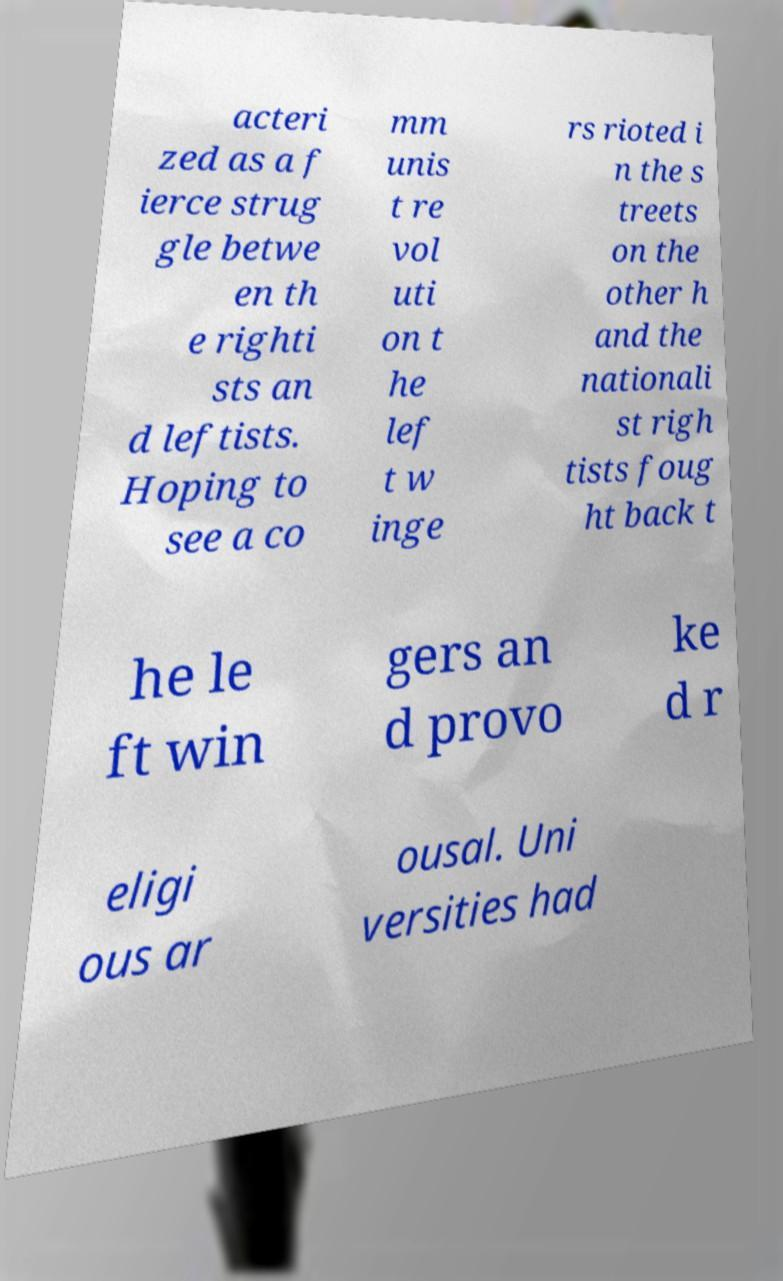Please read and relay the text visible in this image. What does it say? acteri zed as a f ierce strug gle betwe en th e righti sts an d leftists. Hoping to see a co mm unis t re vol uti on t he lef t w inge rs rioted i n the s treets on the other h and the nationali st righ tists foug ht back t he le ft win gers an d provo ke d r eligi ous ar ousal. Uni versities had 